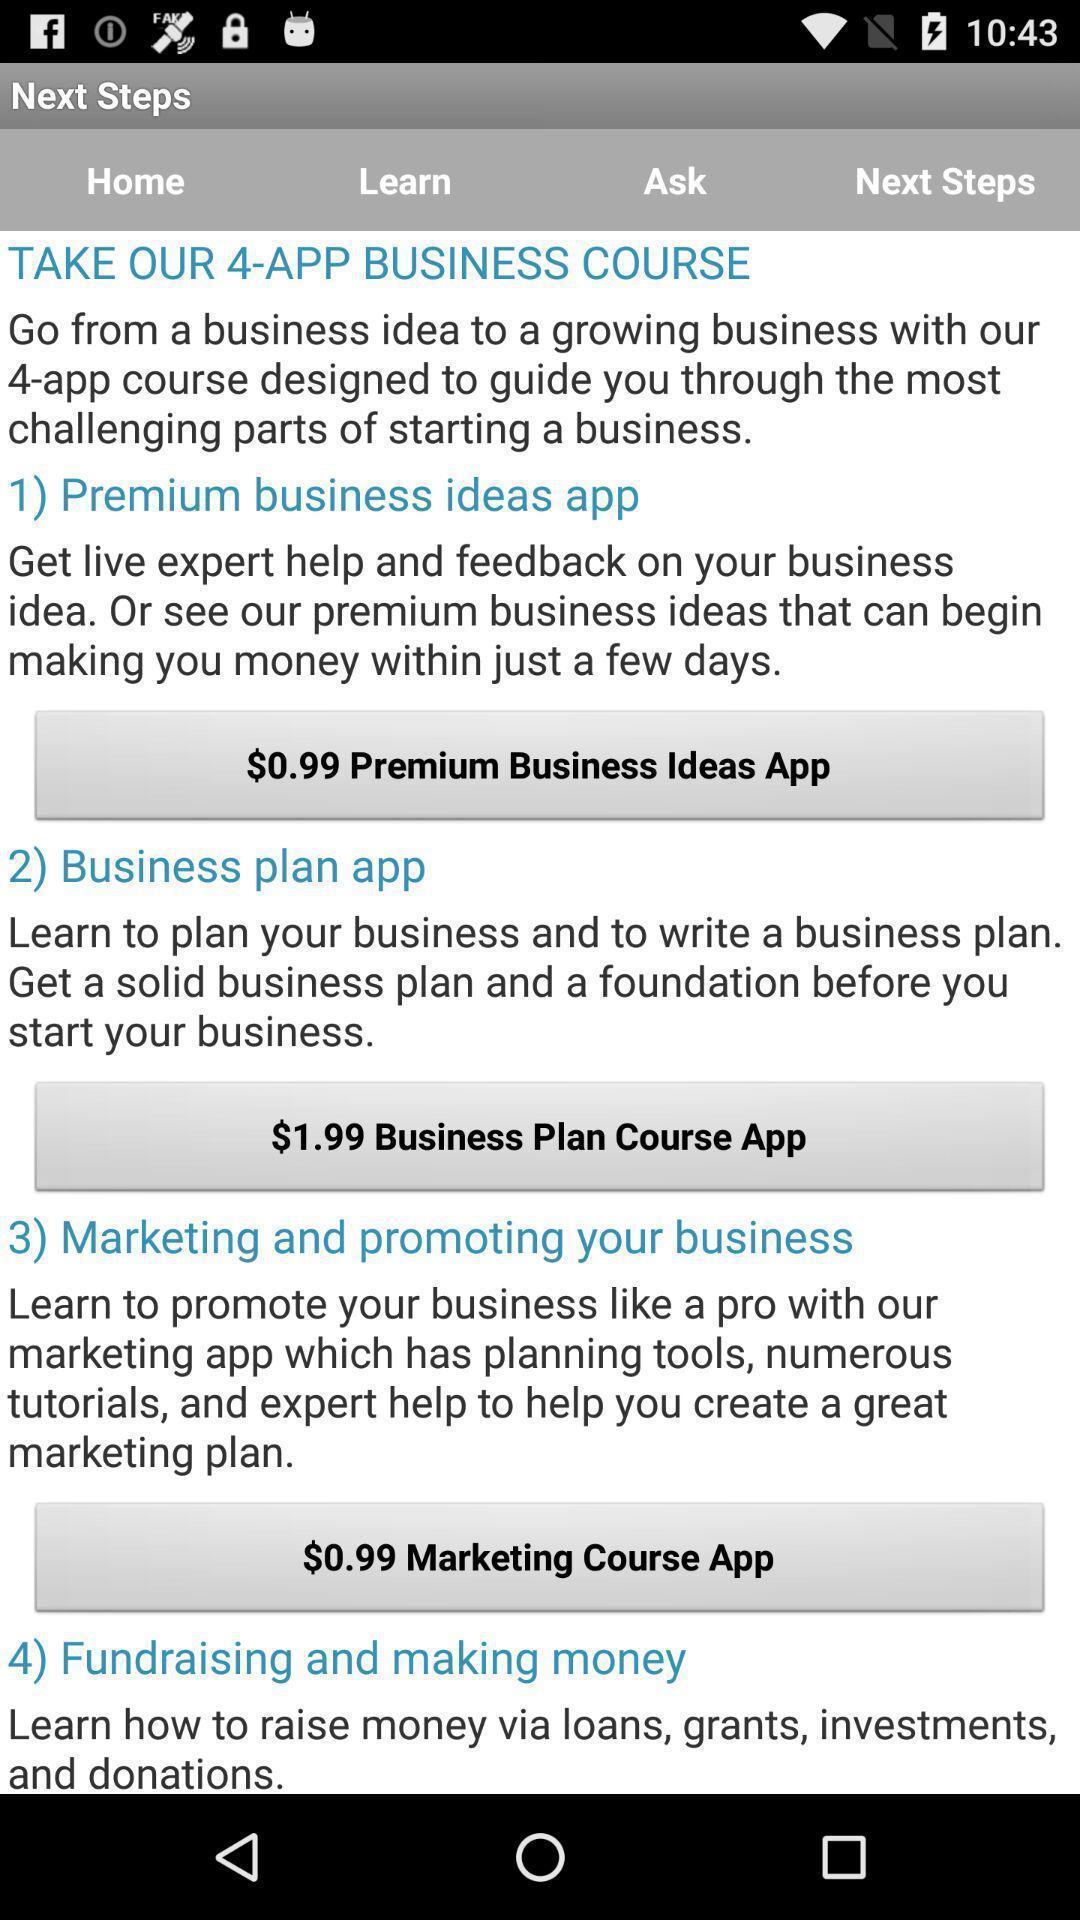Provide a textual representation of this image. Screen displaying list of business plans. 